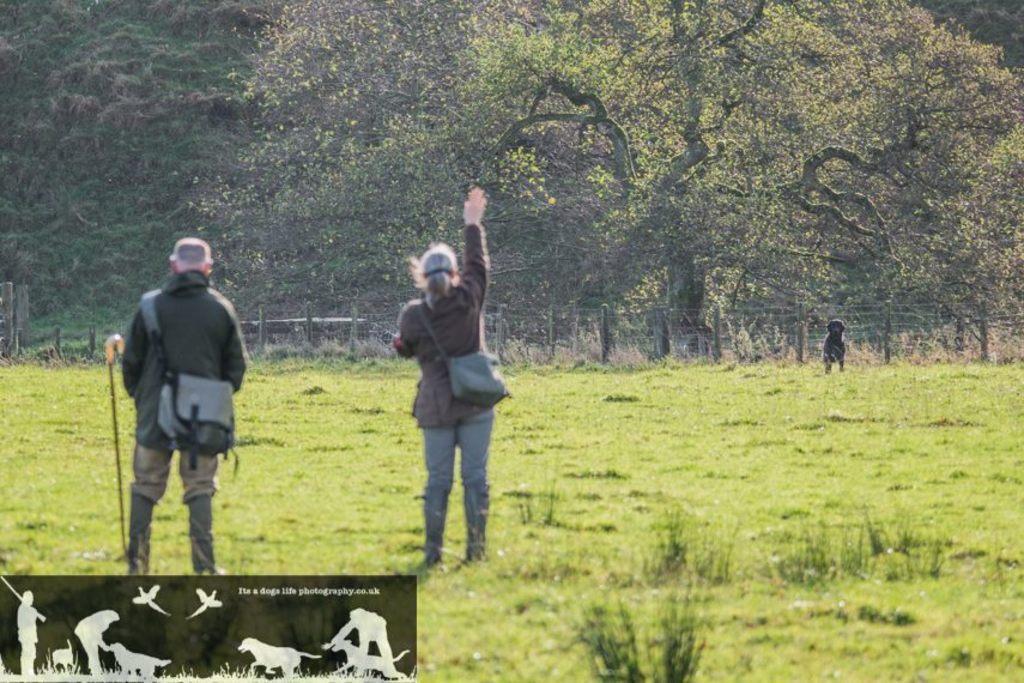In one or two sentences, can you explain what this image depicts? In this picture we can see two persons are standing and carrying bags, at the bottom there is grass, we can see trees, fencing and a dog in the background, there are animated pictures of persons, animals and text at the left bottom. 